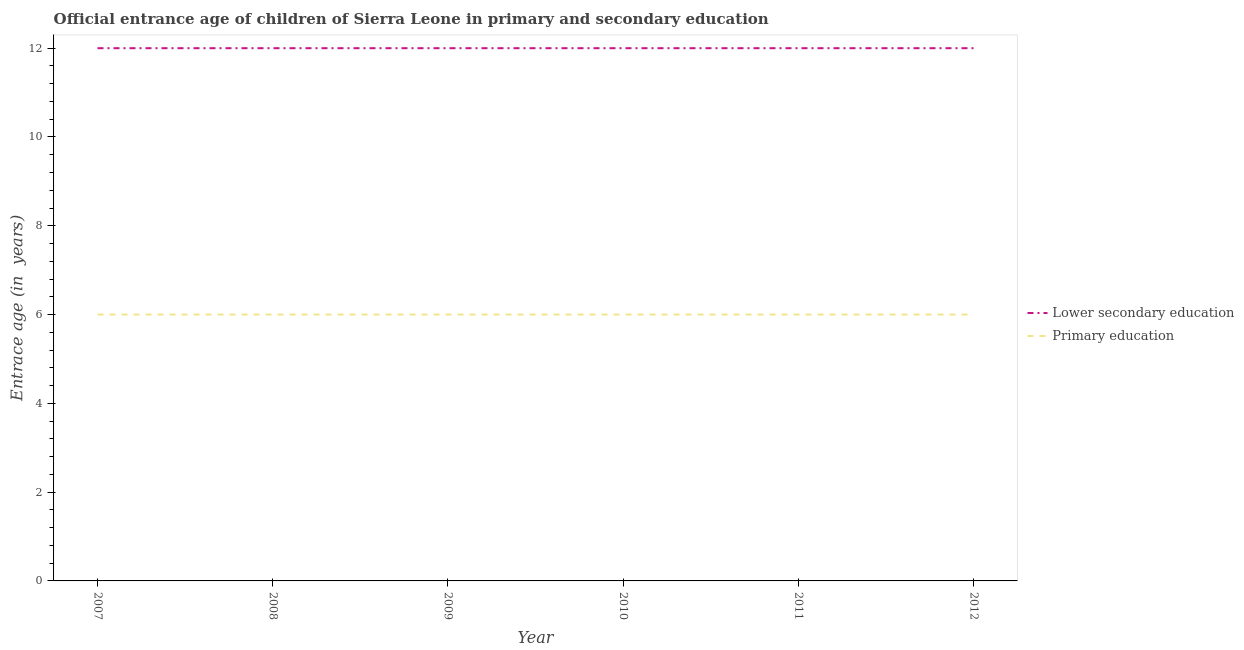How many different coloured lines are there?
Keep it short and to the point. 2. Is the number of lines equal to the number of legend labels?
Offer a terse response. Yes. What is the entrance age of children in lower secondary education in 2008?
Provide a short and direct response. 12. Across all years, what is the minimum entrance age of chiildren in primary education?
Provide a succinct answer. 6. In which year was the entrance age of chiildren in primary education minimum?
Your answer should be very brief. 2007. What is the total entrance age of children in lower secondary education in the graph?
Give a very brief answer. 72. What is the difference between the entrance age of chiildren in primary education in 2012 and the entrance age of children in lower secondary education in 2008?
Give a very brief answer. -6. In the year 2007, what is the difference between the entrance age of chiildren in primary education and entrance age of children in lower secondary education?
Your response must be concise. -6. What is the difference between the highest and the second highest entrance age of chiildren in primary education?
Offer a very short reply. 0. In how many years, is the entrance age of chiildren in primary education greater than the average entrance age of chiildren in primary education taken over all years?
Provide a short and direct response. 0. Is the sum of the entrance age of children in lower secondary education in 2008 and 2010 greater than the maximum entrance age of chiildren in primary education across all years?
Your answer should be compact. Yes. Does the entrance age of children in lower secondary education monotonically increase over the years?
Provide a short and direct response. No. How many lines are there?
Your answer should be very brief. 2. What is the difference between two consecutive major ticks on the Y-axis?
Offer a terse response. 2. How many legend labels are there?
Provide a succinct answer. 2. How are the legend labels stacked?
Your answer should be very brief. Vertical. What is the title of the graph?
Offer a very short reply. Official entrance age of children of Sierra Leone in primary and secondary education. Does "Non-resident workers" appear as one of the legend labels in the graph?
Your response must be concise. No. What is the label or title of the X-axis?
Your response must be concise. Year. What is the label or title of the Y-axis?
Provide a succinct answer. Entrace age (in  years). What is the Entrace age (in  years) of Primary education in 2007?
Make the answer very short. 6. What is the Entrace age (in  years) in Primary education in 2008?
Provide a short and direct response. 6. What is the Entrace age (in  years) of Lower secondary education in 2009?
Your answer should be compact. 12. What is the Entrace age (in  years) in Lower secondary education in 2010?
Ensure brevity in your answer.  12. Across all years, what is the maximum Entrace age (in  years) of Lower secondary education?
Ensure brevity in your answer.  12. Across all years, what is the minimum Entrace age (in  years) in Lower secondary education?
Make the answer very short. 12. Across all years, what is the minimum Entrace age (in  years) in Primary education?
Your response must be concise. 6. What is the total Entrace age (in  years) of Primary education in the graph?
Ensure brevity in your answer.  36. What is the difference between the Entrace age (in  years) of Lower secondary education in 2007 and that in 2010?
Provide a succinct answer. 0. What is the difference between the Entrace age (in  years) of Lower secondary education in 2007 and that in 2011?
Make the answer very short. 0. What is the difference between the Entrace age (in  years) in Primary education in 2007 and that in 2011?
Your answer should be compact. 0. What is the difference between the Entrace age (in  years) of Lower secondary education in 2007 and that in 2012?
Offer a very short reply. 0. What is the difference between the Entrace age (in  years) in Primary education in 2007 and that in 2012?
Provide a short and direct response. 0. What is the difference between the Entrace age (in  years) in Primary education in 2008 and that in 2009?
Offer a terse response. 0. What is the difference between the Entrace age (in  years) in Lower secondary education in 2008 and that in 2010?
Offer a terse response. 0. What is the difference between the Entrace age (in  years) in Primary education in 2008 and that in 2010?
Your response must be concise. 0. What is the difference between the Entrace age (in  years) in Primary education in 2009 and that in 2010?
Your answer should be very brief. 0. What is the difference between the Entrace age (in  years) in Lower secondary education in 2009 and that in 2011?
Keep it short and to the point. 0. What is the difference between the Entrace age (in  years) of Primary education in 2009 and that in 2011?
Your answer should be compact. 0. What is the difference between the Entrace age (in  years) of Primary education in 2010 and that in 2011?
Provide a succinct answer. 0. What is the difference between the Entrace age (in  years) in Primary education in 2010 and that in 2012?
Provide a succinct answer. 0. What is the difference between the Entrace age (in  years) in Lower secondary education in 2011 and that in 2012?
Offer a terse response. 0. What is the difference between the Entrace age (in  years) of Primary education in 2011 and that in 2012?
Your response must be concise. 0. What is the difference between the Entrace age (in  years) in Lower secondary education in 2007 and the Entrace age (in  years) in Primary education in 2008?
Provide a succinct answer. 6. What is the difference between the Entrace age (in  years) of Lower secondary education in 2007 and the Entrace age (in  years) of Primary education in 2010?
Provide a short and direct response. 6. What is the difference between the Entrace age (in  years) in Lower secondary education in 2007 and the Entrace age (in  years) in Primary education in 2011?
Make the answer very short. 6. What is the difference between the Entrace age (in  years) of Lower secondary education in 2008 and the Entrace age (in  years) of Primary education in 2010?
Your answer should be compact. 6. What is the difference between the Entrace age (in  years) of Lower secondary education in 2008 and the Entrace age (in  years) of Primary education in 2012?
Provide a succinct answer. 6. What is the difference between the Entrace age (in  years) in Lower secondary education in 2009 and the Entrace age (in  years) in Primary education in 2011?
Ensure brevity in your answer.  6. What is the difference between the Entrace age (in  years) in Lower secondary education in 2010 and the Entrace age (in  years) in Primary education in 2011?
Ensure brevity in your answer.  6. What is the difference between the Entrace age (in  years) of Lower secondary education in 2011 and the Entrace age (in  years) of Primary education in 2012?
Keep it short and to the point. 6. What is the average Entrace age (in  years) of Lower secondary education per year?
Keep it short and to the point. 12. In the year 2008, what is the difference between the Entrace age (in  years) in Lower secondary education and Entrace age (in  years) in Primary education?
Ensure brevity in your answer.  6. In the year 2009, what is the difference between the Entrace age (in  years) of Lower secondary education and Entrace age (in  years) of Primary education?
Offer a terse response. 6. In the year 2010, what is the difference between the Entrace age (in  years) of Lower secondary education and Entrace age (in  years) of Primary education?
Offer a very short reply. 6. What is the ratio of the Entrace age (in  years) of Primary education in 2007 to that in 2010?
Provide a succinct answer. 1. What is the ratio of the Entrace age (in  years) in Lower secondary education in 2007 to that in 2011?
Your answer should be compact. 1. What is the ratio of the Entrace age (in  years) of Lower secondary education in 2007 to that in 2012?
Ensure brevity in your answer.  1. What is the ratio of the Entrace age (in  years) of Primary education in 2007 to that in 2012?
Your answer should be compact. 1. What is the ratio of the Entrace age (in  years) of Lower secondary education in 2008 to that in 2009?
Your response must be concise. 1. What is the ratio of the Entrace age (in  years) in Primary education in 2008 to that in 2009?
Keep it short and to the point. 1. What is the ratio of the Entrace age (in  years) in Lower secondary education in 2008 to that in 2010?
Keep it short and to the point. 1. What is the ratio of the Entrace age (in  years) in Lower secondary education in 2008 to that in 2011?
Provide a short and direct response. 1. What is the ratio of the Entrace age (in  years) in Primary education in 2008 to that in 2011?
Provide a short and direct response. 1. What is the ratio of the Entrace age (in  years) in Lower secondary education in 2009 to that in 2012?
Give a very brief answer. 1. What is the ratio of the Entrace age (in  years) of Primary education in 2010 to that in 2011?
Give a very brief answer. 1. What is the ratio of the Entrace age (in  years) in Primary education in 2010 to that in 2012?
Keep it short and to the point. 1. What is the ratio of the Entrace age (in  years) in Lower secondary education in 2011 to that in 2012?
Keep it short and to the point. 1. What is the difference between the highest and the second highest Entrace age (in  years) in Lower secondary education?
Provide a short and direct response. 0. What is the difference between the highest and the second highest Entrace age (in  years) in Primary education?
Your answer should be very brief. 0. 